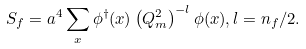Convert formula to latex. <formula><loc_0><loc_0><loc_500><loc_500>S _ { f } = a ^ { 4 } \sum _ { x } \phi ^ { \dagger } ( x ) \left ( Q ^ { 2 } _ { m } \right ) ^ { - l } \phi ( x ) , l = n _ { f } / 2 .</formula> 